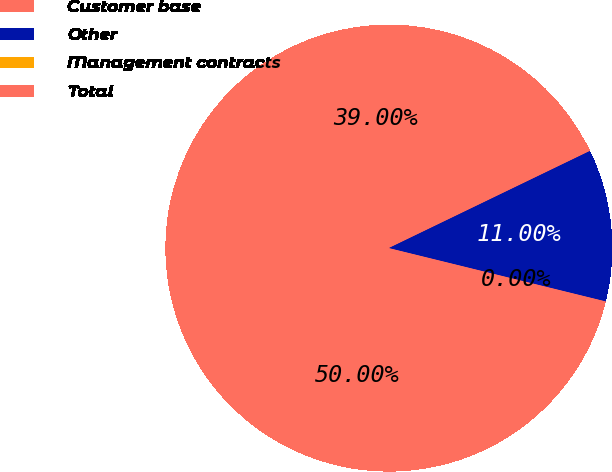Convert chart. <chart><loc_0><loc_0><loc_500><loc_500><pie_chart><fcel>Customer base<fcel>Other<fcel>Management contracts<fcel>Total<nl><fcel>39.0%<fcel>11.0%<fcel>0.0%<fcel>50.0%<nl></chart> 